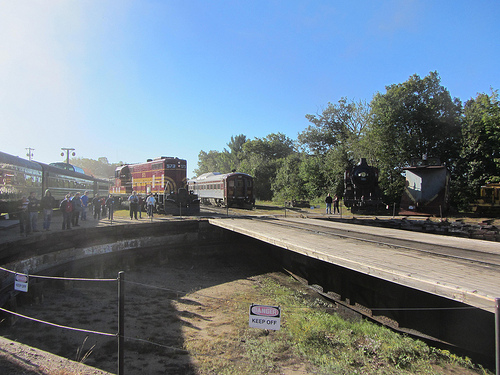Who is on the platform above the dirt? People are standing on the platform above the dirt. 